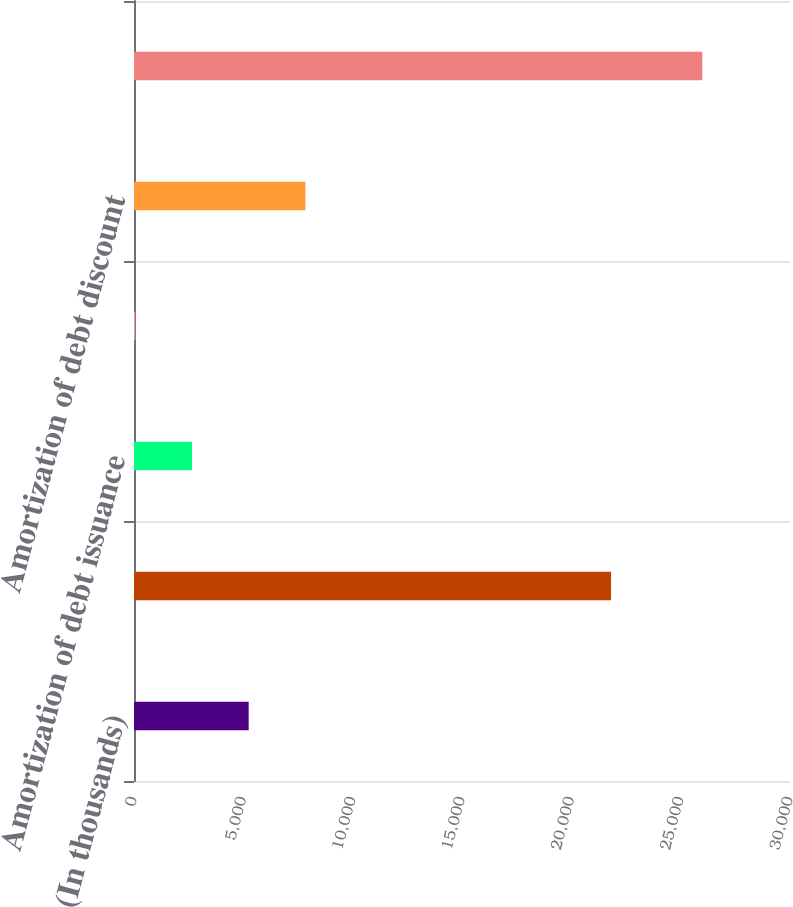<chart> <loc_0><loc_0><loc_500><loc_500><bar_chart><fcel>(In thousands)<fcel>Contractual coupon interest<fcel>Amortization of debt issuance<fcel>Amortization of embedded<fcel>Amortization of debt discount<fcel>Total interest expense related<nl><fcel>5244.2<fcel>21816<fcel>2651.1<fcel>58<fcel>7837.3<fcel>25989<nl></chart> 